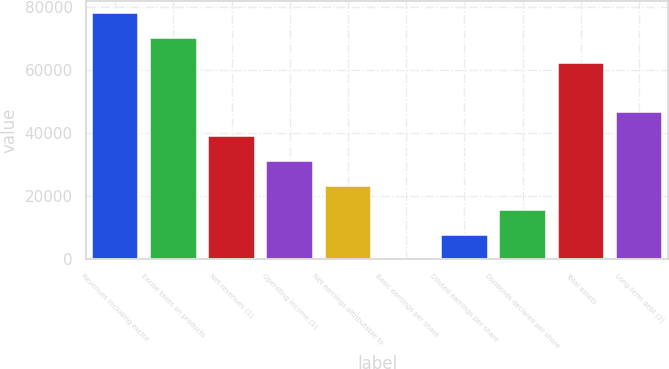<chart> <loc_0><loc_0><loc_500><loc_500><bar_chart><fcel>Revenues including excise<fcel>Excise taxes on products<fcel>Net revenues (1)<fcel>Operating income (1)<fcel>Net earnings attributable to<fcel>Basic earnings per share<fcel>Diluted earnings per share<fcel>Dividends declared per share<fcel>Total assets<fcel>Long-term debt (2)<nl><fcel>78098<fcel>70288.6<fcel>39050.9<fcel>31241.5<fcel>23432.1<fcel>3.88<fcel>7813.29<fcel>15622.7<fcel>62479.2<fcel>46860.3<nl></chart> 